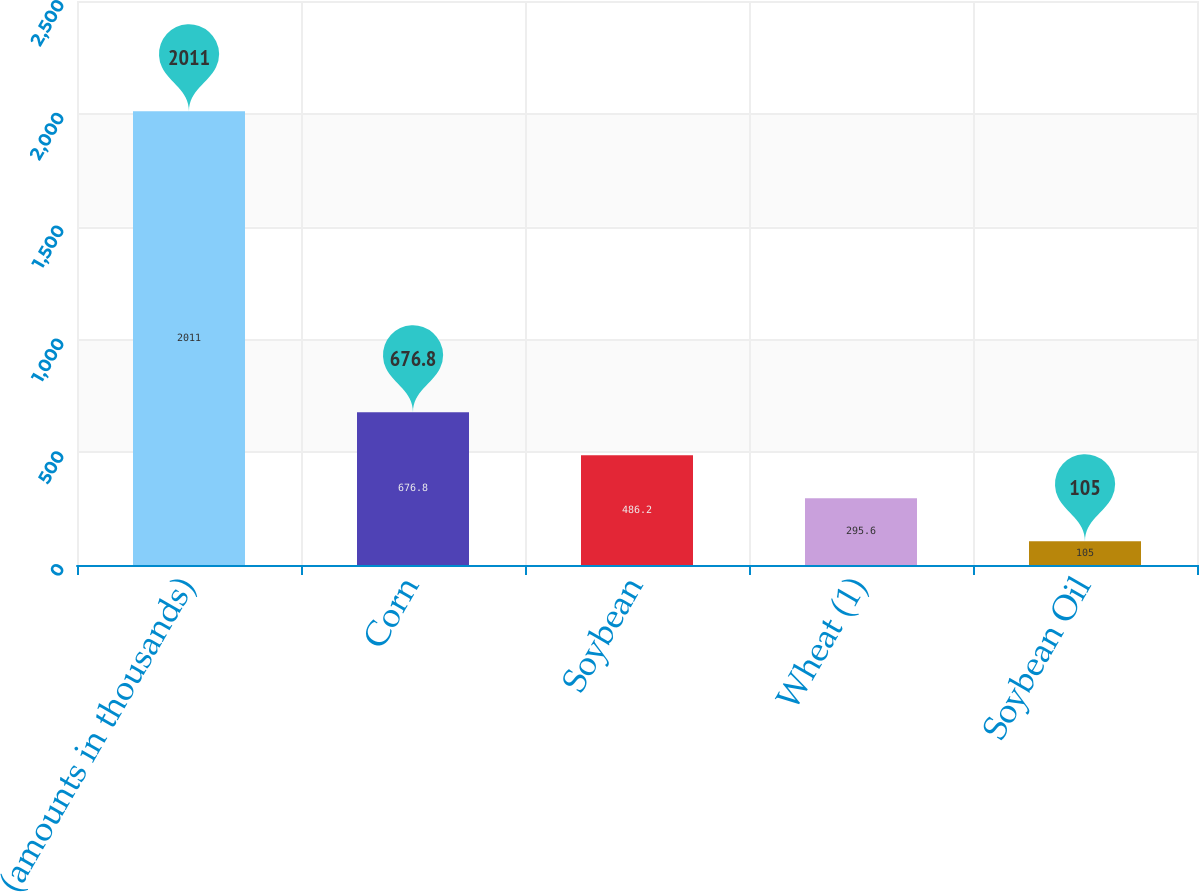<chart> <loc_0><loc_0><loc_500><loc_500><bar_chart><fcel>(amounts in thousands)<fcel>Corn<fcel>Soybean<fcel>Wheat (1)<fcel>Soybean Oil<nl><fcel>2011<fcel>676.8<fcel>486.2<fcel>295.6<fcel>105<nl></chart> 